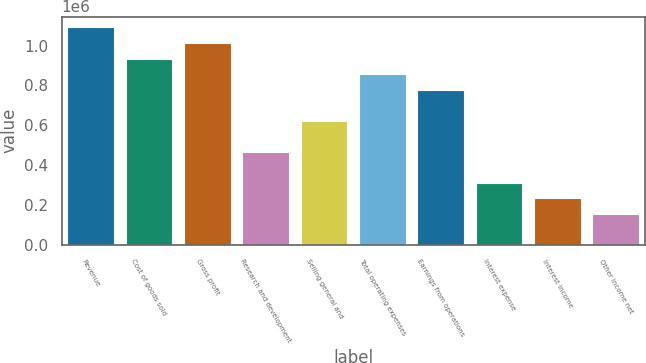<chart> <loc_0><loc_0><loc_500><loc_500><bar_chart><fcel>Revenue<fcel>Cost of goods sold<fcel>Gross profit<fcel>Research and development<fcel>Selling general and<fcel>Total operating expenses<fcel>Earnings from operations<fcel>Interest expense<fcel>Interest income<fcel>Other income net<nl><fcel>1.09116e+06<fcel>935276<fcel>1.01322e+06<fcel>467639<fcel>623518<fcel>857337<fcel>779397<fcel>311759<fcel>233820<fcel>155880<nl></chart> 